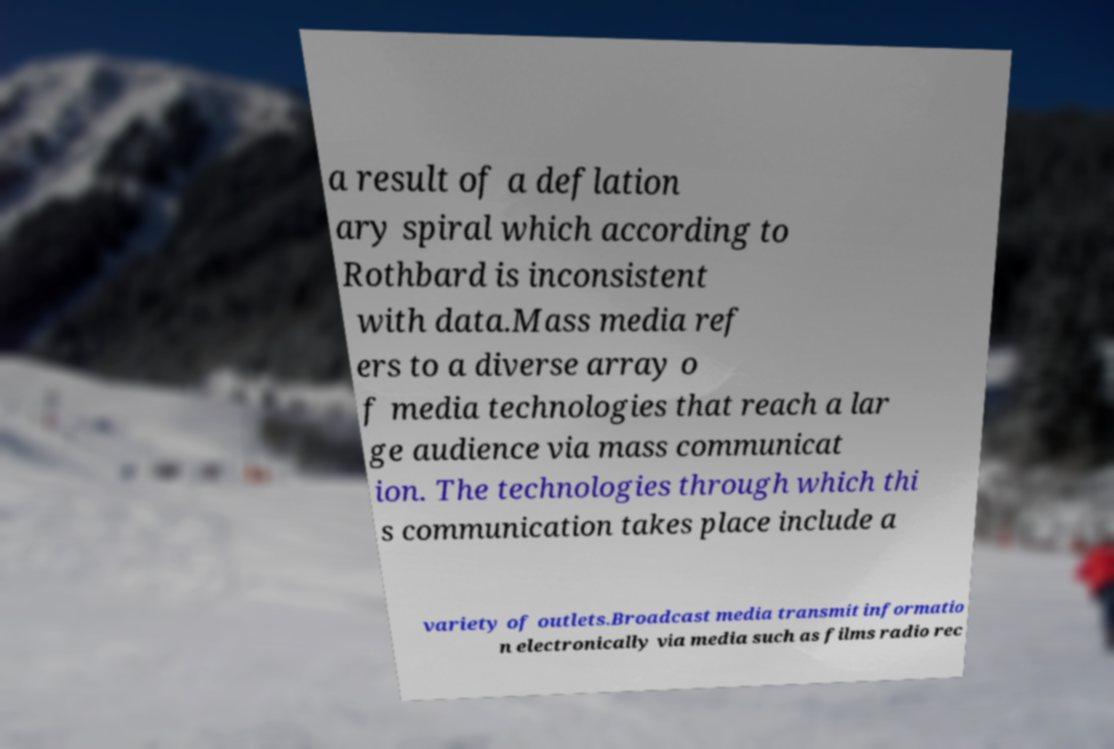Can you accurately transcribe the text from the provided image for me? a result of a deflation ary spiral which according to Rothbard is inconsistent with data.Mass media ref ers to a diverse array o f media technologies that reach a lar ge audience via mass communicat ion. The technologies through which thi s communication takes place include a variety of outlets.Broadcast media transmit informatio n electronically via media such as films radio rec 